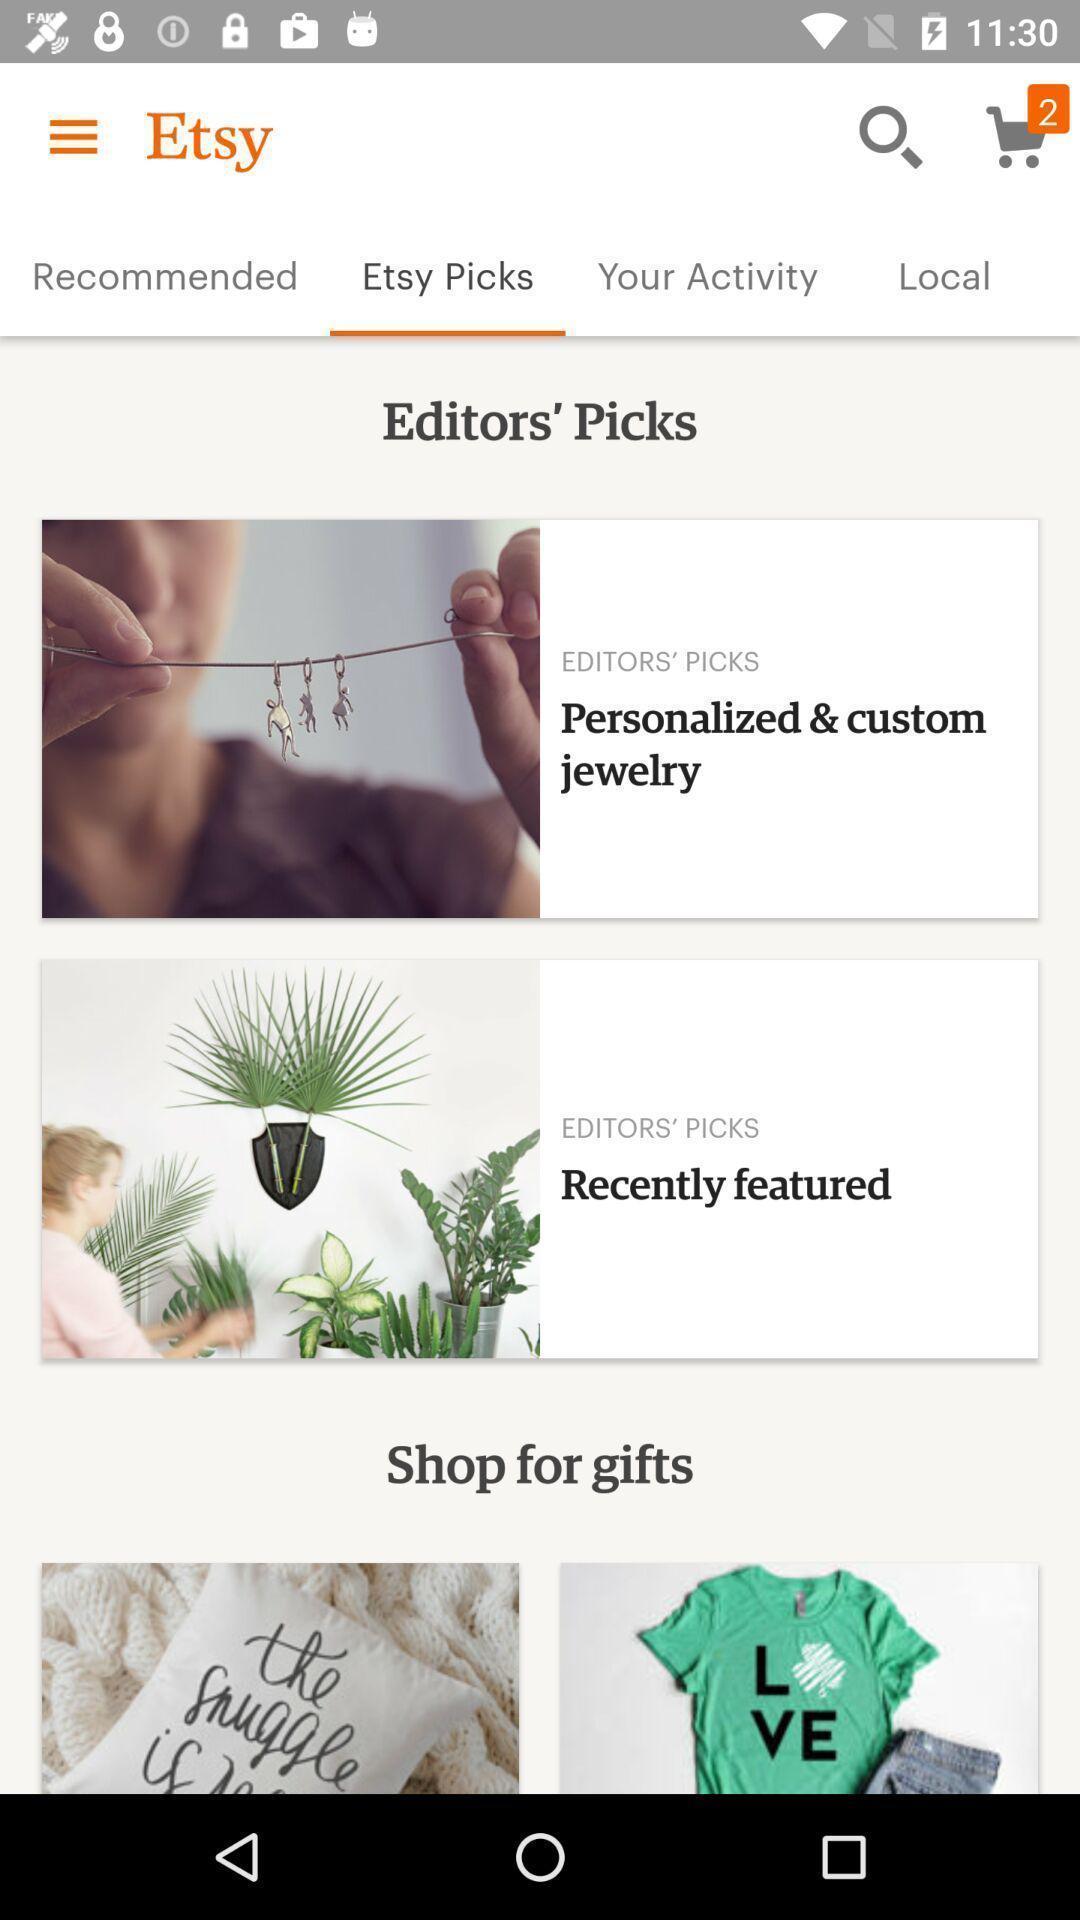Provide a detailed account of this screenshot. Screen shows some editors picks. 